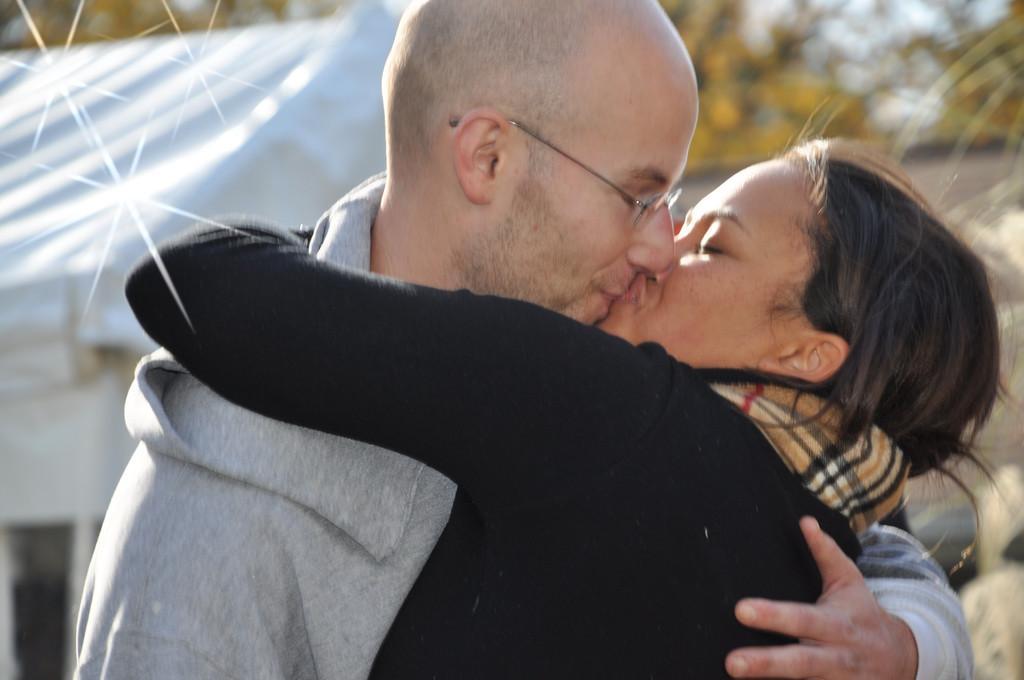Describe this image in one or two sentences. In this image, we can see a woman and man are kissing and hugging each other. Background we can see a blur. Here we can see a tent and trees. 